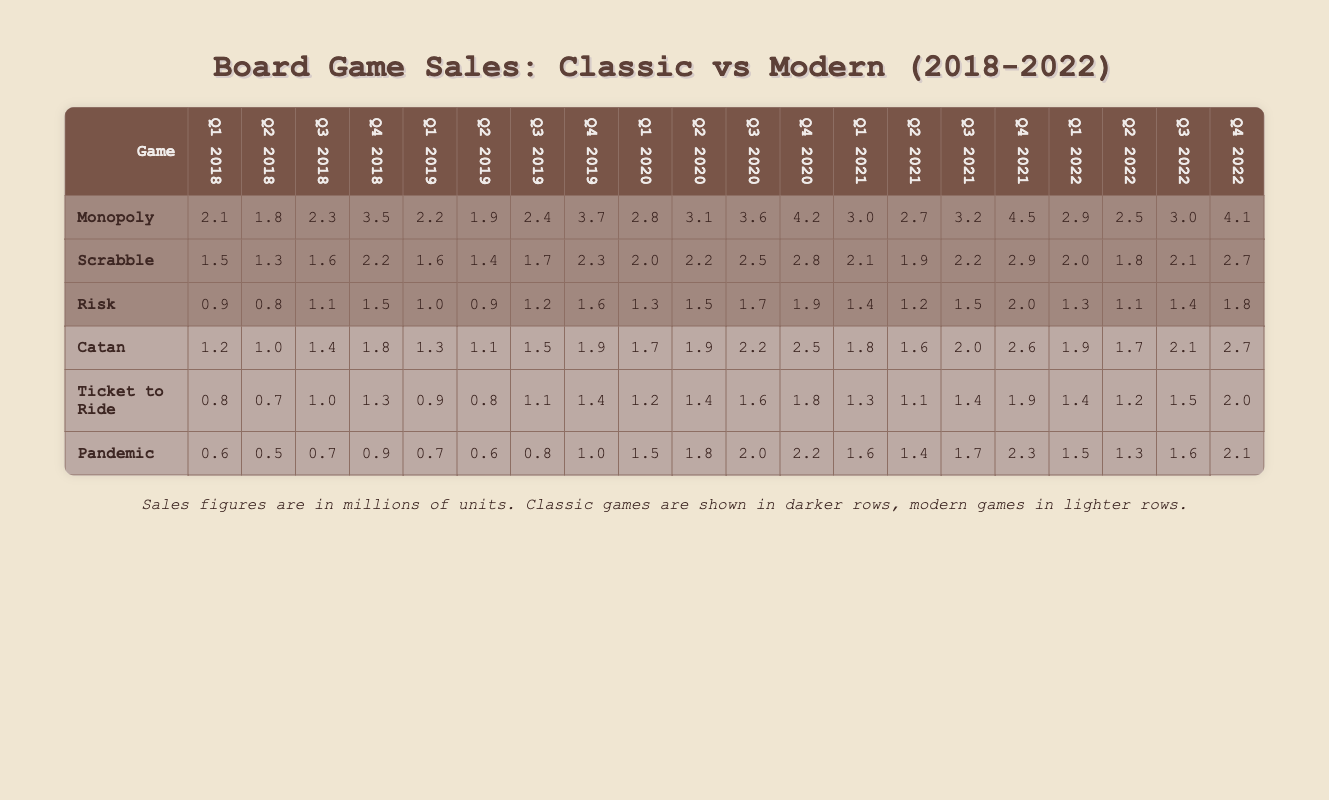What were the total sales figures for Monopoly in Q4 2020? According to the table, the sales figure for Monopoly in Q4 2020 is 4.2 million units.
Answer: 4.2 million units Which game had the highest sales in Q3 2022? Scrabble had sales of 2.1 million, Monopoly had 3.0 million, Risk had 1.4 million, Catan had 2.1 million, Ticket to Ride had 1.5 million, and Pandemic had 1.6 million. The highest of these is Monopoly at 3.0 million.
Answer: Monopoly What is the average sales figure for all classic games in Q2 2020? The sales figures for classic games in Q2 2020 are Monopoly (3.1), Scrabble (2.2), and Risk (1.5). Summing these gives 3.1 + 2.2 + 1.5 = 6.8 million, dividing by 3 games gives an average of 6.8 / 3 = 2.27 million.
Answer: 2.27 million Did Pandemic have higher sales than Ticket to Ride in Q1 2022? Pandemic's sales in Q1 2022 were 1.5 million, while Ticket to Ride had sales of 1.4 million. Since 1.5 million is greater than 1.4 million, the statement is true.
Answer: Yes What was the total sales for modern games in 2021? The sales figures for modern games in 2021 are as follows: Catan (1.8 + 1.6 + 2.0 + 2.6 = 8.0), Ticket to Ride (1.3 + 1.1 + 1.4 + 1.9 = 5.7), and Pandemic (1.6 + 1.4 + 1.7 + 2.3 = 7.0). Adding these totals gives 8.0 + 5.7 + 7.0 = 20.7 million.
Answer: 20.7 million What is the difference in sales between Monopoly and Risk in Q1 2019? In Q1 2019, Monopoly had sales of 2.2 million, while Risk had sales of 1.0 million. The difference is 2.2 - 1.0 = 1.2 million.
Answer: 1.2 million Which game showed the most growth in sales from Q1 2018 to Q4 2022? To determine this, we calculate the sales difference for each game from Q1 2018 to Q4 2022. For Monopoly, it went from 2.1 to 4.1 (4.1 - 2.1 = 2.0 million), Scrabble from 1.5 to 2.7 (2.7 - 1.5 = 1.2 million), and Risk from 0.9 to 1.8 (1.8 - 0.9 = 0.9 million). The highest growth is Monopoly with 2.0 million.
Answer: Monopoly What were the total sales for all classic games in Q2 2018? In Q2 2018, the sales figures for classic games were: Monopoly (1.8 million), Scrabble (1.3 million), and Risk (0.8 million). The total sales for these games are 1.8 + 1.3 + 0.8 = 3.9 million.
Answer: 3.9 million Was the sales figure for Scrabble in Q4 2021 greater than the sales figure for Catan in Q1 2022? The sales figure for Scrabble in Q4 2021 was 2.9 million, while the sales figure for Catan in Q1 2022 was 1.9 million. Since 2.9 million is greater than 1.9 million, the statement is true.
Answer: Yes 